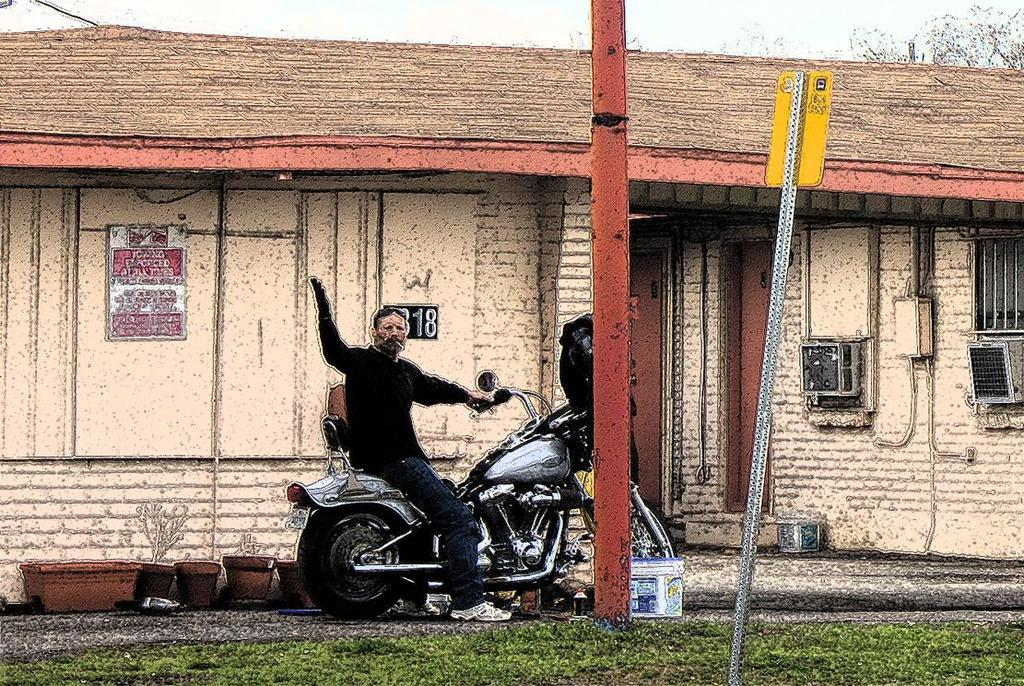Who is the main subject in the image? There is a man in the image. What is the man doing in the image? The man is sitting on a bike. What can be seen in the background of the image? There is a building and a sign board in the background of the image. What type of cable is the man using to ride the bike in the image? There is no mention of a cable in the image, and the man is not using any cable to ride the bike. 